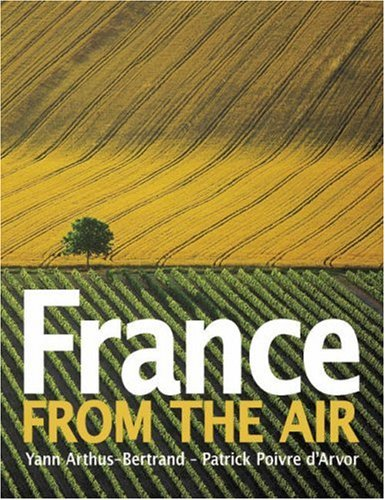What type of book is this? This is a book categorized under Arts & Photography, focusing primarily on visual representations of French landscapes through aerial imagery. 